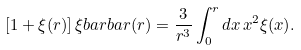<formula> <loc_0><loc_0><loc_500><loc_500>[ 1 + \xi ( r ) ] \, \xi b a r b a r ( r ) = \frac { 3 } { r ^ { 3 } } \int _ { 0 } ^ { r } d x \, x ^ { 2 } \xi ( x ) .</formula> 